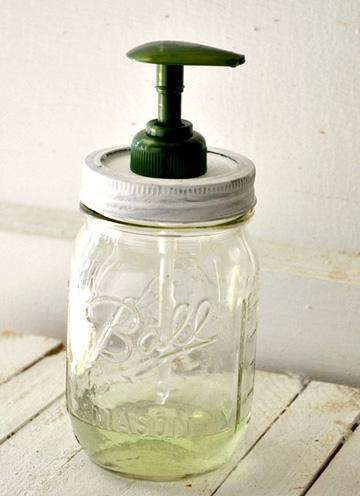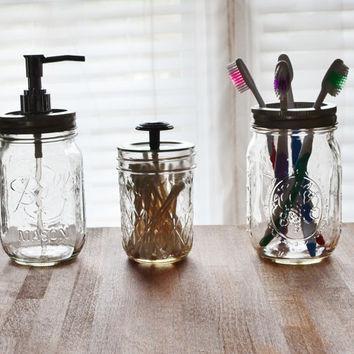The first image is the image on the left, the second image is the image on the right. Considering the images on both sides, is "Each image shows a pair of pump dispensers, and each pair of dispensers is shown with a caddy holder." valid? Answer yes or no. No. The first image is the image on the left, the second image is the image on the right. For the images shown, is this caption "Two jars are sitting in a carrier in one of the images." true? Answer yes or no. No. 